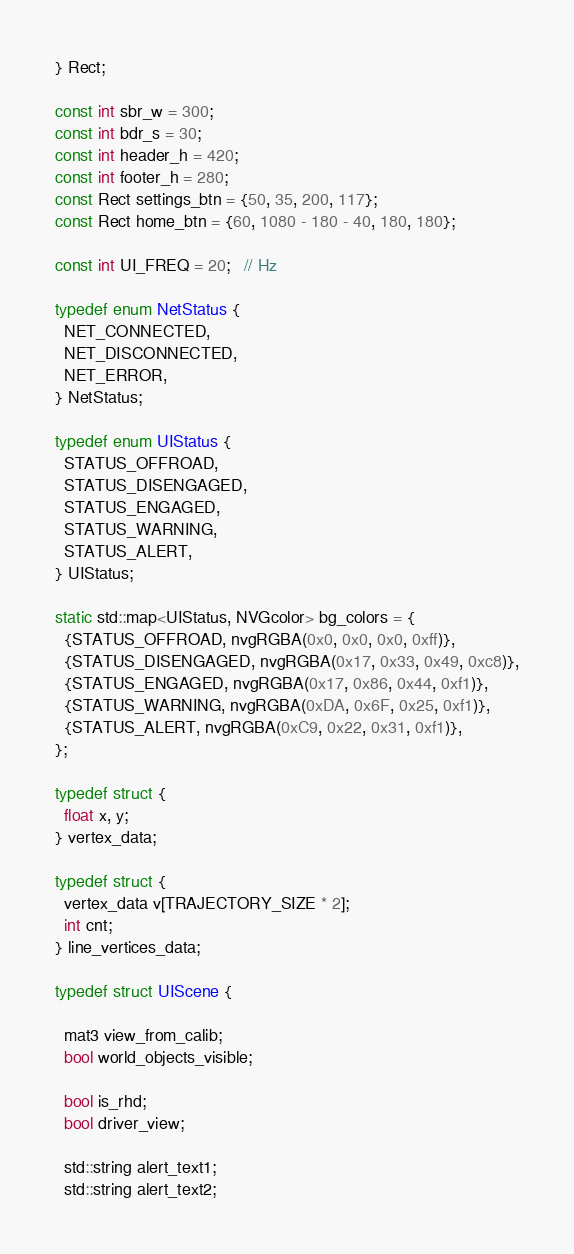Convert code to text. <code><loc_0><loc_0><loc_500><loc_500><_C++_>} Rect;

const int sbr_w = 300;
const int bdr_s = 30;
const int header_h = 420;
const int footer_h = 280;
const Rect settings_btn = {50, 35, 200, 117};
const Rect home_btn = {60, 1080 - 180 - 40, 180, 180};

const int UI_FREQ = 20;   // Hz

typedef enum NetStatus {
  NET_CONNECTED,
  NET_DISCONNECTED,
  NET_ERROR,
} NetStatus;

typedef enum UIStatus {
  STATUS_OFFROAD,
  STATUS_DISENGAGED,
  STATUS_ENGAGED,
  STATUS_WARNING,
  STATUS_ALERT,
} UIStatus;

static std::map<UIStatus, NVGcolor> bg_colors = {
  {STATUS_OFFROAD, nvgRGBA(0x0, 0x0, 0x0, 0xff)},
  {STATUS_DISENGAGED, nvgRGBA(0x17, 0x33, 0x49, 0xc8)},
  {STATUS_ENGAGED, nvgRGBA(0x17, 0x86, 0x44, 0xf1)},
  {STATUS_WARNING, nvgRGBA(0xDA, 0x6F, 0x25, 0xf1)},
  {STATUS_ALERT, nvgRGBA(0xC9, 0x22, 0x31, 0xf1)},
};

typedef struct {
  float x, y;
} vertex_data;

typedef struct {
  vertex_data v[TRAJECTORY_SIZE * 2];
  int cnt;
} line_vertices_data;

typedef struct UIScene {

  mat3 view_from_calib;
  bool world_objects_visible;

  bool is_rhd;
  bool driver_view;

  std::string alert_text1;
  std::string alert_text2;</code> 